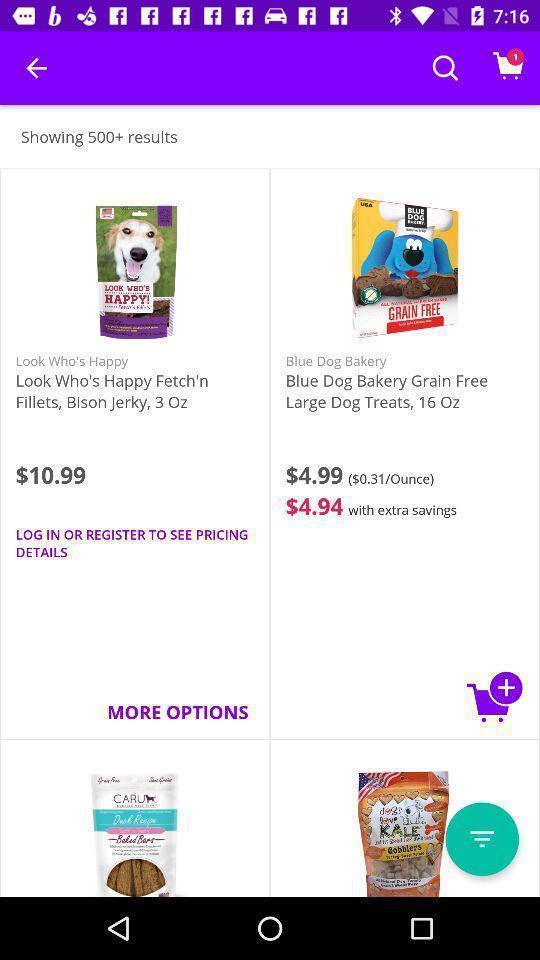What is the overall content of this screenshot? Page shows product with the price in an service application. 